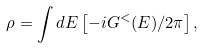Convert formula to latex. <formula><loc_0><loc_0><loc_500><loc_500>\rho = \int d E \left [ - i G ^ { < } ( E ) / 2 \pi \right ] ,</formula> 